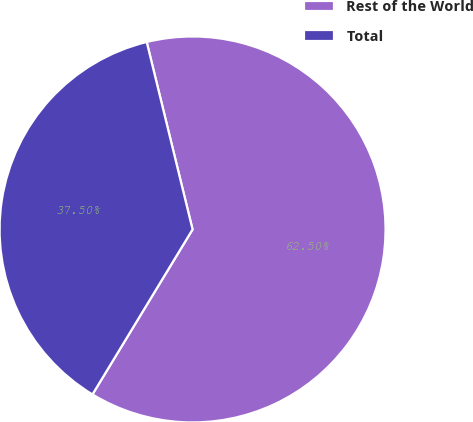Convert chart. <chart><loc_0><loc_0><loc_500><loc_500><pie_chart><fcel>Rest of the World<fcel>Total<nl><fcel>62.5%<fcel>37.5%<nl></chart> 